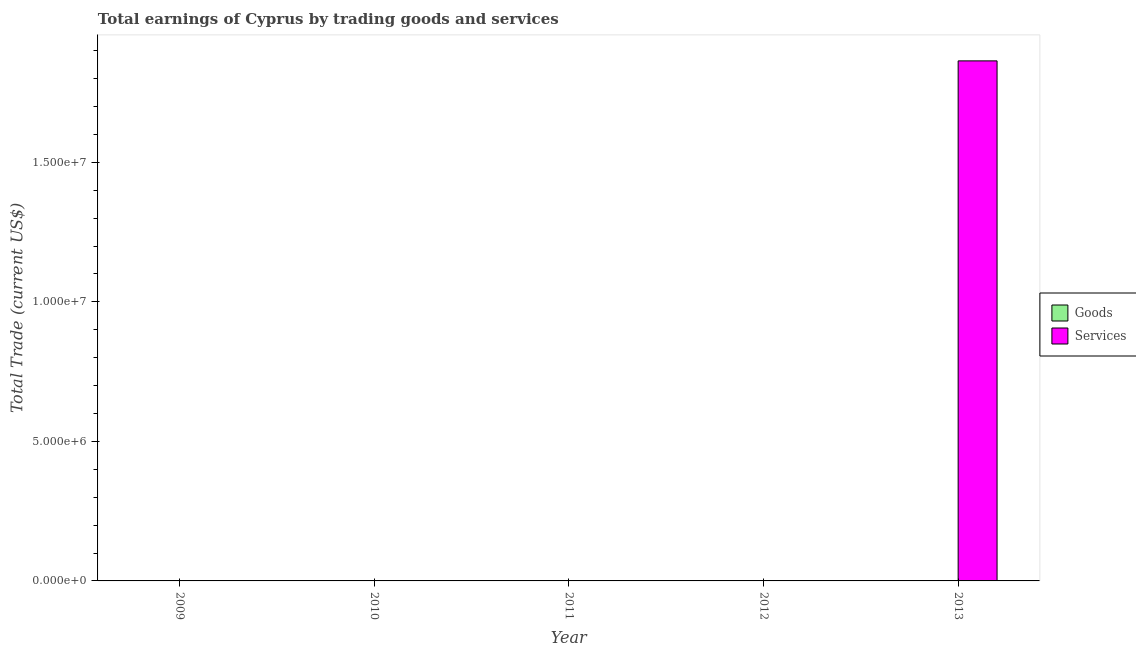Are the number of bars per tick equal to the number of legend labels?
Offer a very short reply. No. Are the number of bars on each tick of the X-axis equal?
Keep it short and to the point. No. How many bars are there on the 5th tick from the left?
Offer a terse response. 1. How many bars are there on the 5th tick from the right?
Your answer should be very brief. 0. What is the label of the 1st group of bars from the left?
Make the answer very short. 2009. In how many cases, is the number of bars for a given year not equal to the number of legend labels?
Keep it short and to the point. 5. What is the amount earned by trading services in 2010?
Make the answer very short. 0. Across all years, what is the maximum amount earned by trading services?
Your response must be concise. 1.86e+07. Across all years, what is the minimum amount earned by trading goods?
Your answer should be very brief. 0. In which year was the amount earned by trading services maximum?
Offer a terse response. 2013. What is the total amount earned by trading services in the graph?
Your answer should be very brief. 1.86e+07. What is the difference between the amount earned by trading services in 2011 and the amount earned by trading goods in 2010?
Your answer should be very brief. 0. In how many years, is the amount earned by trading services greater than 3000000 US$?
Give a very brief answer. 1. What is the difference between the highest and the lowest amount earned by trading services?
Offer a very short reply. 1.86e+07. In how many years, is the amount earned by trading services greater than the average amount earned by trading services taken over all years?
Your answer should be very brief. 1. How many bars are there?
Offer a terse response. 1. Are all the bars in the graph horizontal?
Keep it short and to the point. No. What is the difference between two consecutive major ticks on the Y-axis?
Ensure brevity in your answer.  5.00e+06. Are the values on the major ticks of Y-axis written in scientific E-notation?
Your answer should be very brief. Yes. Does the graph contain grids?
Your response must be concise. No. How many legend labels are there?
Keep it short and to the point. 2. How are the legend labels stacked?
Your answer should be very brief. Vertical. What is the title of the graph?
Your response must be concise. Total earnings of Cyprus by trading goods and services. Does "Taxes on exports" appear as one of the legend labels in the graph?
Your answer should be very brief. No. What is the label or title of the X-axis?
Provide a short and direct response. Year. What is the label or title of the Y-axis?
Offer a very short reply. Total Trade (current US$). What is the Total Trade (current US$) of Services in 2010?
Give a very brief answer. 0. What is the Total Trade (current US$) of Services in 2011?
Ensure brevity in your answer.  0. What is the Total Trade (current US$) in Services in 2013?
Your answer should be compact. 1.86e+07. Across all years, what is the maximum Total Trade (current US$) of Services?
Your response must be concise. 1.86e+07. What is the total Total Trade (current US$) of Goods in the graph?
Provide a short and direct response. 0. What is the total Total Trade (current US$) of Services in the graph?
Offer a very short reply. 1.86e+07. What is the average Total Trade (current US$) in Services per year?
Your answer should be compact. 3.73e+06. What is the difference between the highest and the lowest Total Trade (current US$) of Services?
Offer a very short reply. 1.86e+07. 